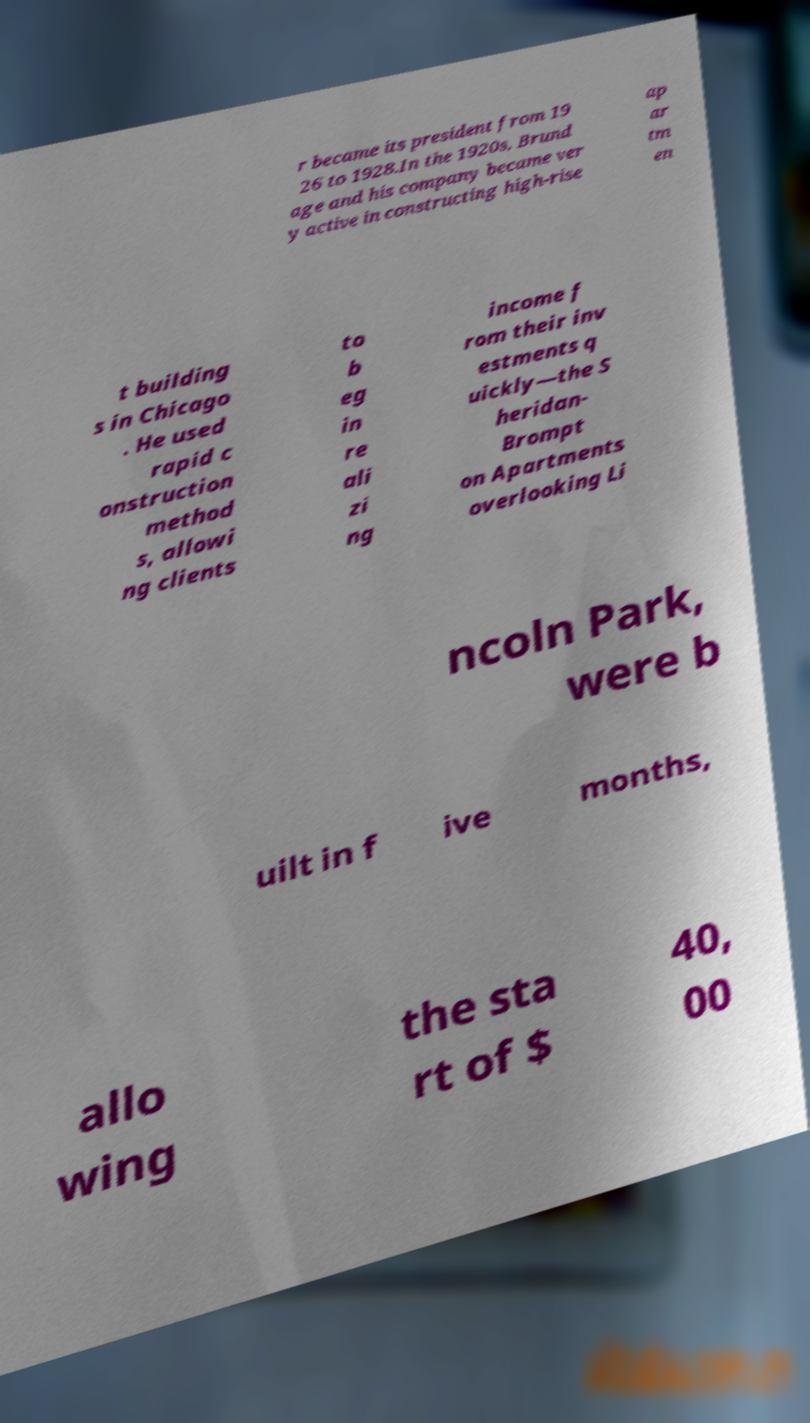I need the written content from this picture converted into text. Can you do that? r became its president from 19 26 to 1928.In the 1920s, Brund age and his company became ver y active in constructing high-rise ap ar tm en t building s in Chicago . He used rapid c onstruction method s, allowi ng clients to b eg in re ali zi ng income f rom their inv estments q uickly—the S heridan- Brompt on Apartments overlooking Li ncoln Park, were b uilt in f ive months, allo wing the sta rt of $ 40, 00 